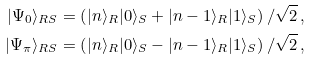<formula> <loc_0><loc_0><loc_500><loc_500>| \Psi _ { 0 } \rangle _ { R S } & = \left ( | n \rangle _ { R } | 0 \rangle _ { S } + | n - 1 \rangle _ { R } | 1 \rangle _ { S } \right ) / \sqrt { 2 } \, , \\ | \Psi _ { \pi } \rangle _ { R S } & = \left ( | n \rangle _ { R } | 0 \rangle _ { S } - | n - 1 \rangle _ { R } | 1 \rangle _ { S } \right ) / \sqrt { 2 } \, ,</formula> 